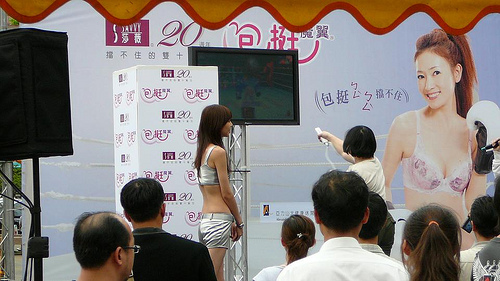Identify the text displayed in this image. 90 20 20 20 